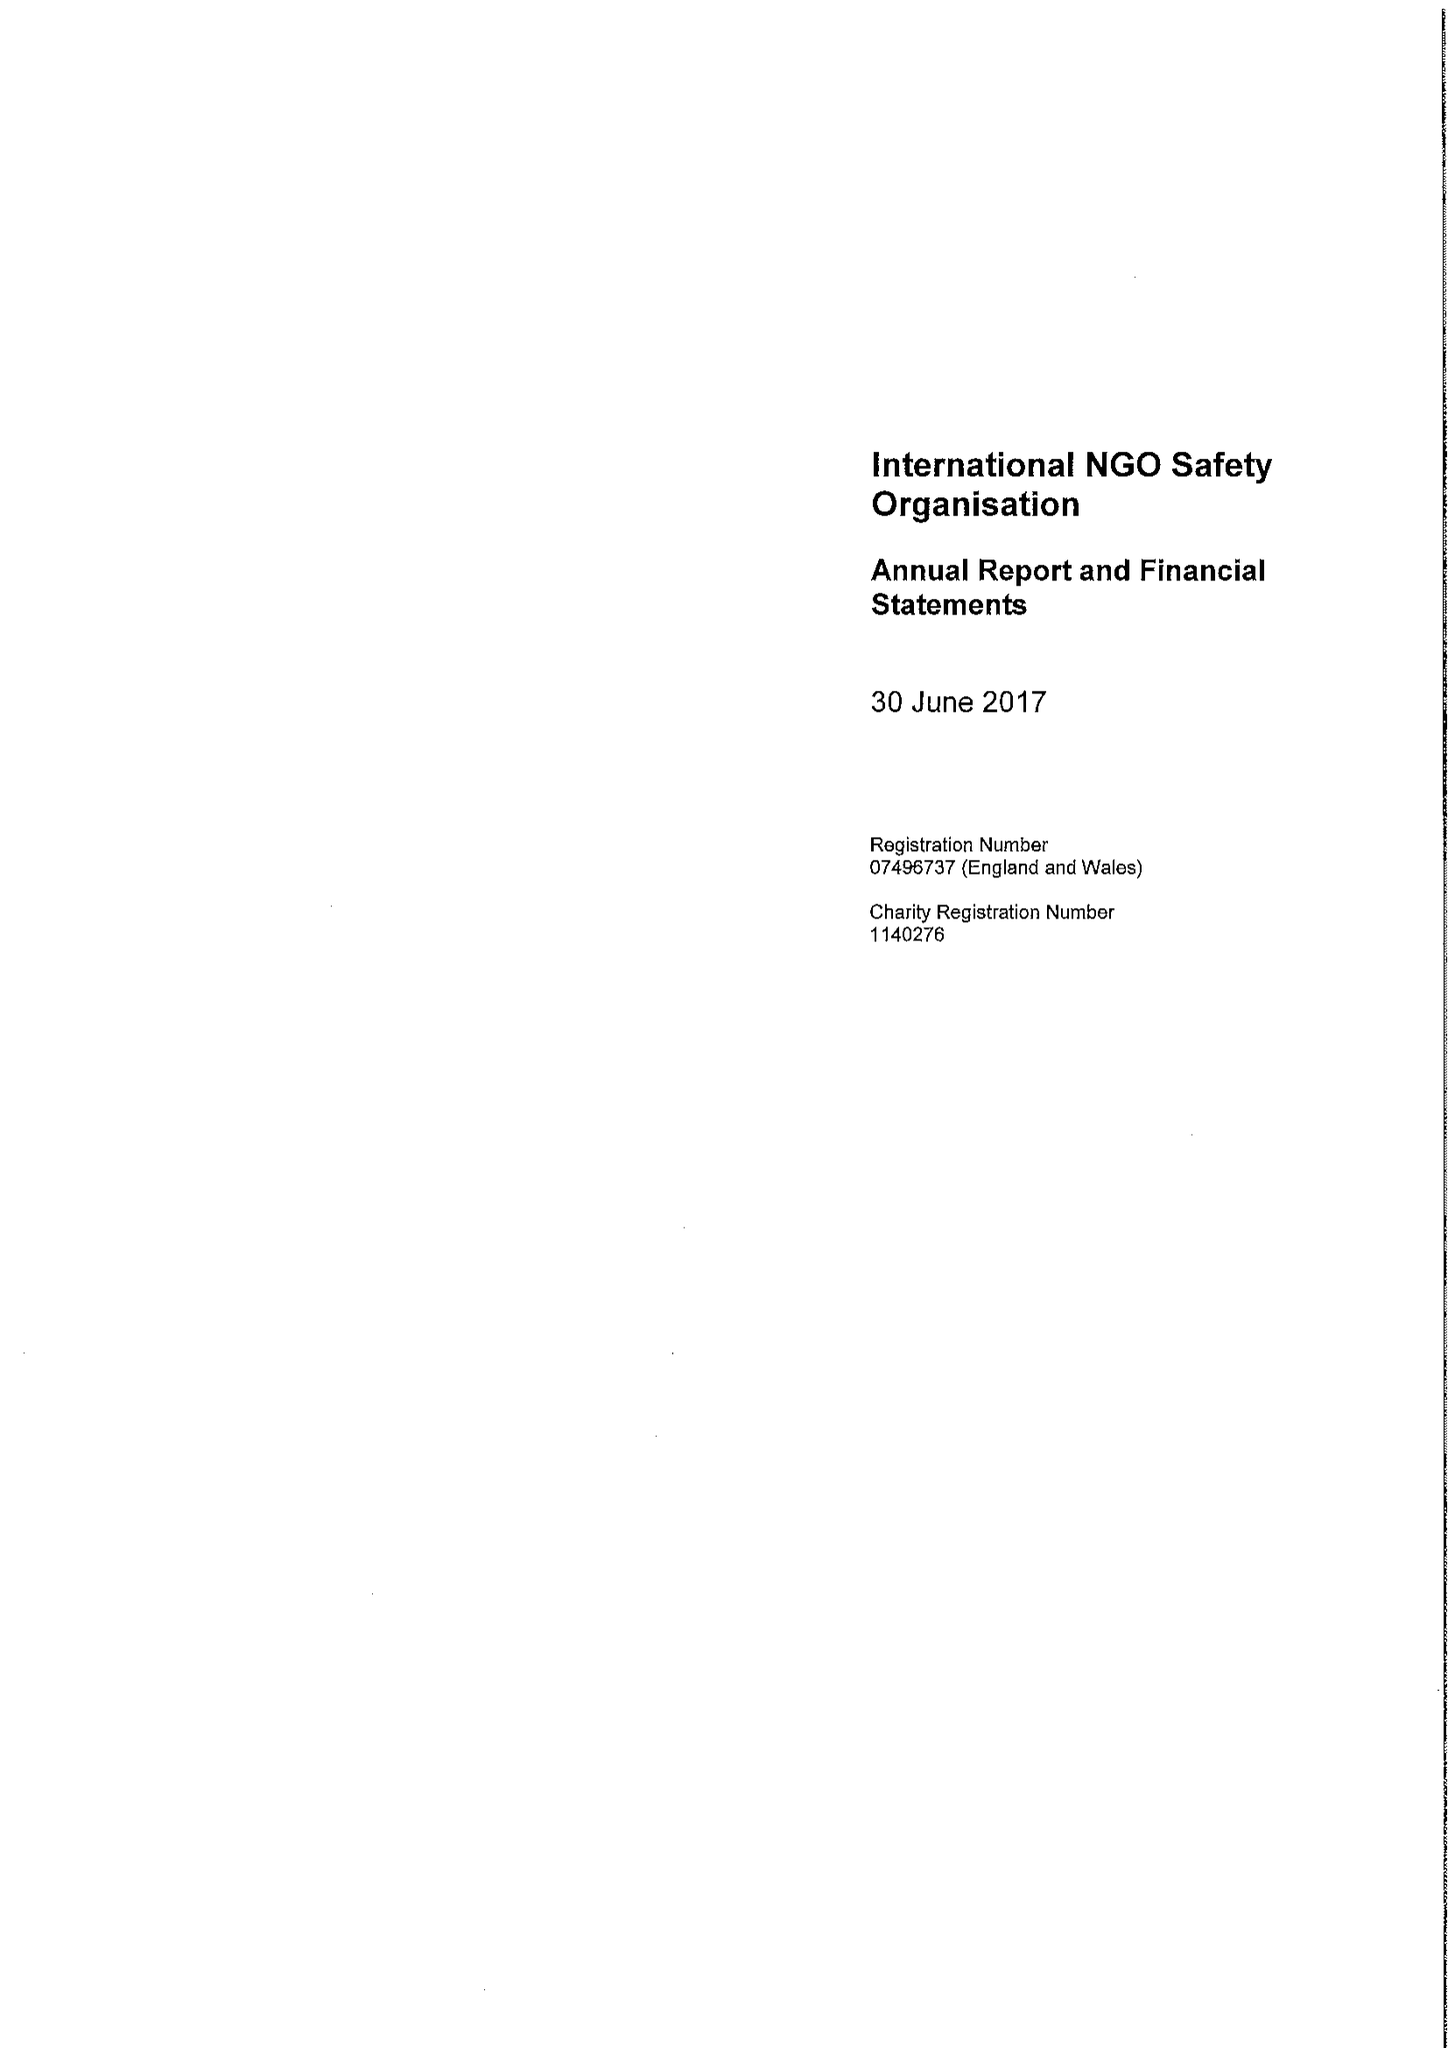What is the value for the address__street_line?
Answer the question using a single word or phrase. 10 QUEEN STREET PLACE 